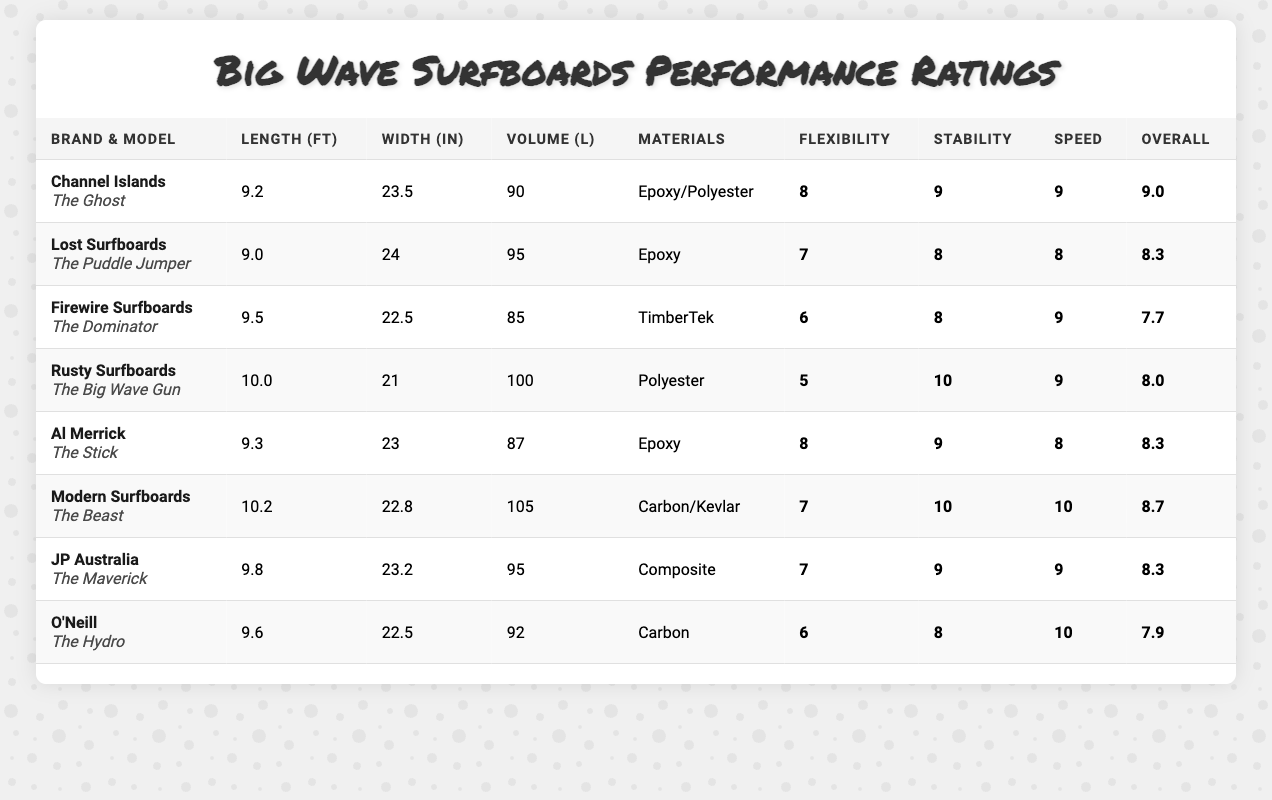What is the highest Overall Performance rating and which surfboard has it? From the table, Channel Islands - The Ghost has the highest Overall Performance rating of 9.0.
Answer: 9.0, Channel Islands - The Ghost Which surfboard has the highest Stability Rating? The Big Wave Gun by Rusty Surfboards has the highest Stability Rating of 10.
Answer: Rusty Surfboards - The Big Wave Gun What is the average Length of the surfboards listed? To find the average length, sum the lengths: (9.2 + 9.0 + 9.5 + 10.0 + 9.3 + 10.2 + 9.8 + 9.6) = 77.6. There are 8 surfboards, so the average is 77.6 / 8 = 9.7 ft.
Answer: 9.7 ft Does any surfboard have a Flexibility Rating of 10? By checking the Flexibility Ratings listed in the table, none of the surfboards have a Flexibility Rating of 10.
Answer: No Which surfboard has the lowest Speed Rating, and what is that rating? The Dominator by Firewire Surfboards has the lowest Speed Rating of 6.
Answer: Firewire Surfboards - The Dominator, 6 If we consider just the surfboards made from Epoxy materials, what is their average Overall Performance rating? The surfboards made from Epoxy materials are The Ghost, The Puddle Jumper, and The Stick, with Overall Performance ratings of 9.0, 8.3, and 8.3 respectively. The average is (9.0 + 8.3 + 8.3) / 3 = 8.533, rounded to 8.5.
Answer: 8.5 Which surfboard has the largest Volume, and what is that Volume? The Big Wave Gun by Rusty Surfboards has the largest Volume of 100 liters.
Answer: Rusty Surfboards - The Big Wave Gun, 100 L Compare the Flexibility Ratings of the top two surfboards based on Overall Performance, what is the difference? The Ghost has a Flexibility Rating of 8, while the second highest, The Beast, has a Flexibility Rating of 7. The difference is 8 - 7 = 1.
Answer: 1 Are there more surfboards with an Overall Performance rating above 8 than below? There are 5 surfboards with Overall Performance above 8 (The Ghost, The Beast, The Puddle Jumper, The Stick, The Maverick) and 3 with below (The Dominator, The Big Wave Gun, The Hydro). Since 5 is greater than 3, the answer is yes.
Answer: Yes What are the materials used for the surfboard with the highest Overall Performance? The surfboard with the highest Overall Performance is The Ghost by Channel Islands, and it is made of Epoxy/Polyester.
Answer: Epoxy/Polyester 